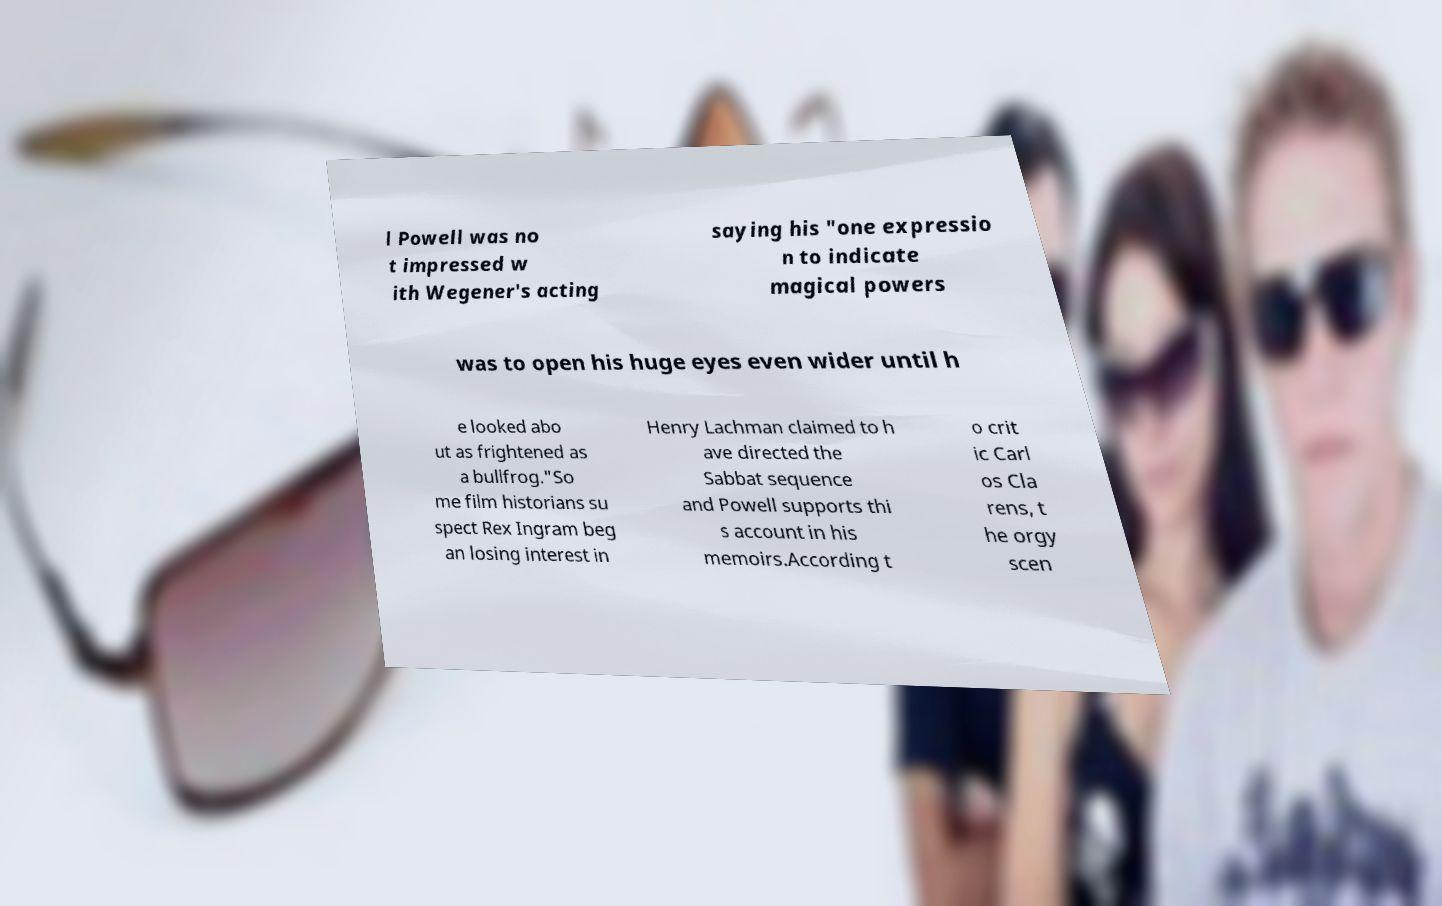Can you read and provide the text displayed in the image?This photo seems to have some interesting text. Can you extract and type it out for me? l Powell was no t impressed w ith Wegener's acting saying his "one expressio n to indicate magical powers was to open his huge eyes even wider until h e looked abo ut as frightened as a bullfrog."So me film historians su spect Rex Ingram beg an losing interest in Henry Lachman claimed to h ave directed the Sabbat sequence and Powell supports thi s account in his memoirs.According t o crit ic Carl os Cla rens, t he orgy scen 